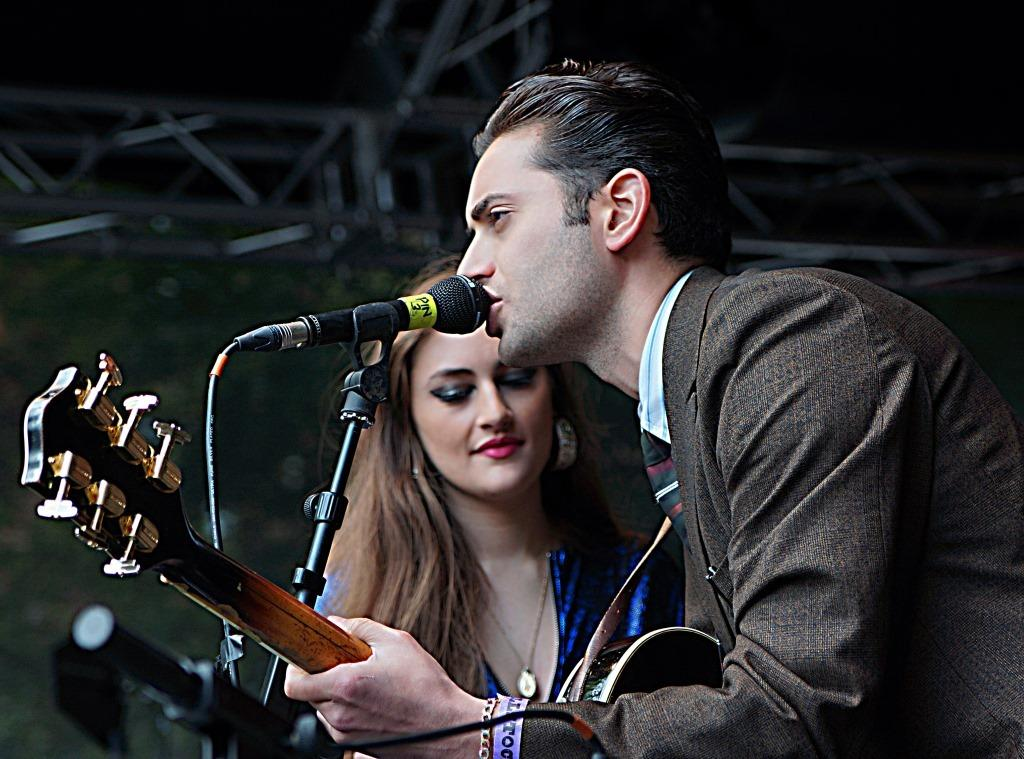What is the man in the image doing? The man is standing and holding a guitar. What object is in front of the man? There is a microphone in front of the man. Who is standing beside the man? There is a woman standing beside the man. What type of chalk is the man using to draw on the glass in the image? There is no chalk or glass present in the image. What medical advice is the doctor giving to the man in the image? There is no doctor present in the image. 